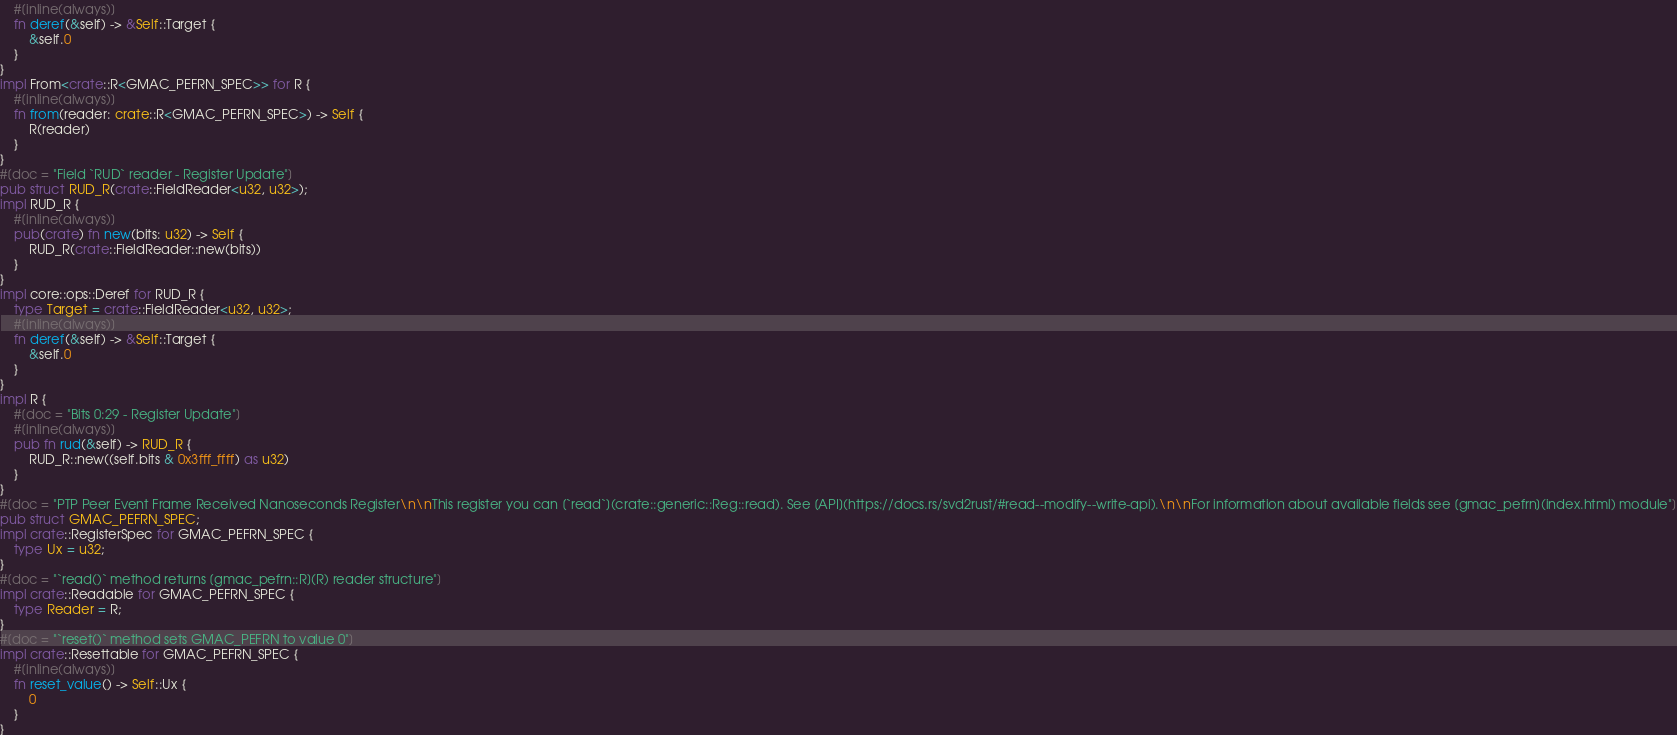<code> <loc_0><loc_0><loc_500><loc_500><_Rust_>    #[inline(always)]
    fn deref(&self) -> &Self::Target {
        &self.0
    }
}
impl From<crate::R<GMAC_PEFRN_SPEC>> for R {
    #[inline(always)]
    fn from(reader: crate::R<GMAC_PEFRN_SPEC>) -> Self {
        R(reader)
    }
}
#[doc = "Field `RUD` reader - Register Update"]
pub struct RUD_R(crate::FieldReader<u32, u32>);
impl RUD_R {
    #[inline(always)]
    pub(crate) fn new(bits: u32) -> Self {
        RUD_R(crate::FieldReader::new(bits))
    }
}
impl core::ops::Deref for RUD_R {
    type Target = crate::FieldReader<u32, u32>;
    #[inline(always)]
    fn deref(&self) -> &Self::Target {
        &self.0
    }
}
impl R {
    #[doc = "Bits 0:29 - Register Update"]
    #[inline(always)]
    pub fn rud(&self) -> RUD_R {
        RUD_R::new((self.bits & 0x3fff_ffff) as u32)
    }
}
#[doc = "PTP Peer Event Frame Received Nanoseconds Register\n\nThis register you can [`read`](crate::generic::Reg::read). See [API](https://docs.rs/svd2rust/#read--modify--write-api).\n\nFor information about available fields see [gmac_pefrn](index.html) module"]
pub struct GMAC_PEFRN_SPEC;
impl crate::RegisterSpec for GMAC_PEFRN_SPEC {
    type Ux = u32;
}
#[doc = "`read()` method returns [gmac_pefrn::R](R) reader structure"]
impl crate::Readable for GMAC_PEFRN_SPEC {
    type Reader = R;
}
#[doc = "`reset()` method sets GMAC_PEFRN to value 0"]
impl crate::Resettable for GMAC_PEFRN_SPEC {
    #[inline(always)]
    fn reset_value() -> Self::Ux {
        0
    }
}
</code> 